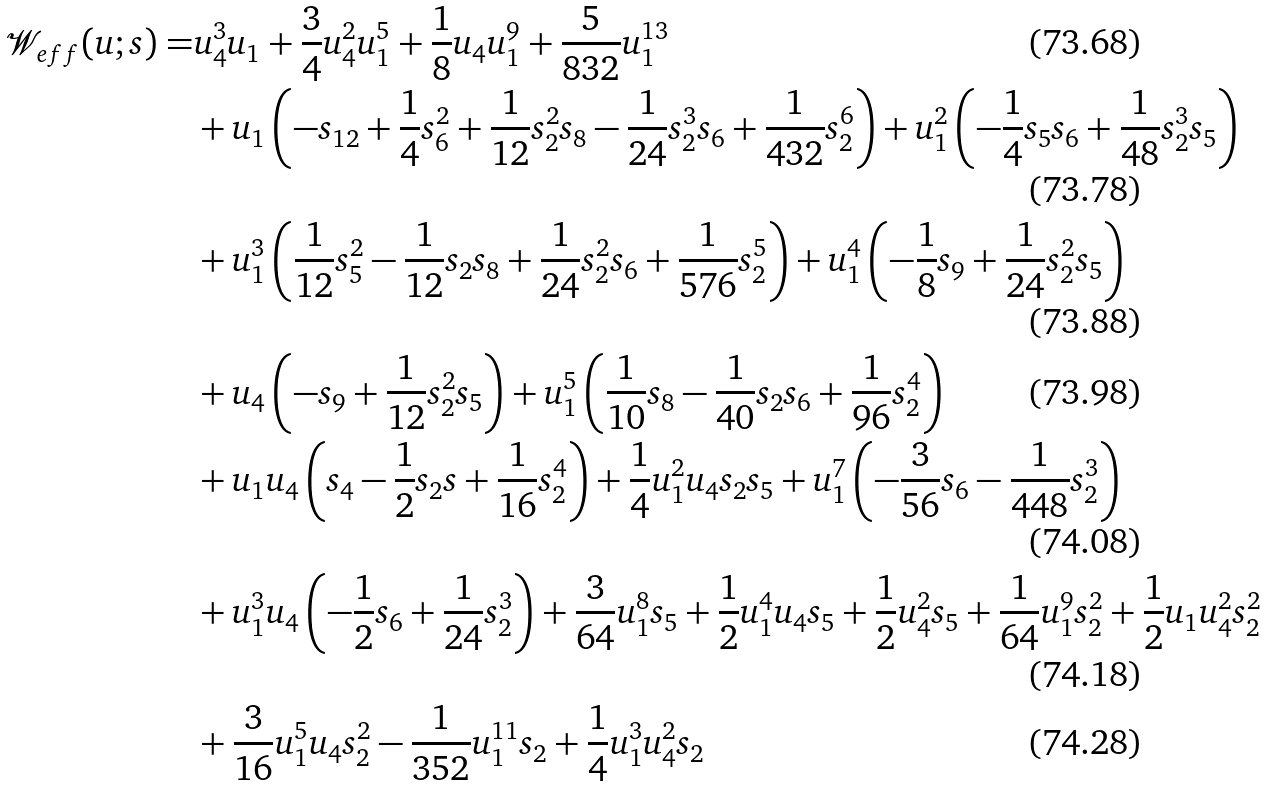<formula> <loc_0><loc_0><loc_500><loc_500>\mathcal { W } _ { e f f } ( u ; s ) = & u _ { 4 } ^ { 3 } u _ { 1 } + \frac { 3 } { 4 } u _ { 4 } ^ { 2 } u _ { 1 } ^ { 5 } + \frac { 1 } { 8 } u _ { 4 } u _ { 1 } ^ { 9 } + \frac { 5 } { 8 3 2 } u _ { 1 } ^ { 1 3 } \\ & + u _ { 1 } \left ( - s _ { 1 2 } + \frac { 1 } { 4 } s _ { 6 } ^ { 2 } + \frac { 1 } { 1 2 } s _ { 2 } ^ { 2 } s _ { 8 } - \frac { 1 } { 2 4 } s _ { 2 } ^ { 3 } s _ { 6 } + \frac { 1 } { 4 3 2 } s _ { 2 } ^ { 6 } \right ) + u _ { 1 } ^ { 2 } \left ( - \frac { 1 } { 4 } s _ { 5 } s _ { 6 } + \frac { 1 } { 4 8 } s _ { 2 } ^ { 3 } s _ { 5 } \right ) \\ & + u _ { 1 } ^ { 3 } \left ( \frac { 1 } { 1 2 } s _ { 5 } ^ { 2 } - \frac { 1 } { 1 2 } s _ { 2 } s _ { 8 } + \frac { 1 } { 2 4 } s _ { 2 } ^ { 2 } s _ { 6 } + \frac { 1 } { 5 7 6 } s _ { 2 } ^ { 5 } \right ) + u _ { 1 } ^ { 4 } \left ( - \frac { 1 } { 8 } s _ { 9 } + \frac { 1 } { 2 4 } s _ { 2 } ^ { 2 } s _ { 5 } \right ) \\ & + u _ { 4 } \left ( - s _ { 9 } + \frac { 1 } { 1 2 } s _ { 2 } ^ { 2 } s _ { 5 } \right ) + u _ { 1 } ^ { 5 } \left ( \frac { 1 } { 1 0 } s _ { 8 } - \frac { 1 } { 4 0 } s _ { 2 } s _ { 6 } + \frac { 1 } { 9 6 } s _ { 2 } ^ { 4 } \right ) \\ & + u _ { 1 } u _ { 4 } \left ( s _ { 4 } - \frac { 1 } { 2 } s _ { 2 } s + \frac { 1 } { 1 6 } s _ { 2 } ^ { 4 } \right ) + \frac { 1 } { 4 } u _ { 1 } ^ { 2 } u _ { 4 } s _ { 2 } s _ { 5 } + u _ { 1 } ^ { 7 } \left ( - \frac { 3 } { 5 6 } s _ { 6 } - \frac { 1 } { 4 4 8 } s _ { 2 } ^ { 3 } \right ) \\ & + u _ { 1 } ^ { 3 } u _ { 4 } \left ( - \frac { 1 } { 2 } s _ { 6 } + \frac { 1 } { 2 4 } s _ { 2 } ^ { 3 } \right ) + \frac { 3 } { 6 4 } u _ { 1 } ^ { 8 } s _ { 5 } + \frac { 1 } { 2 } u _ { 1 } ^ { 4 } u _ { 4 } s _ { 5 } + \frac { 1 } { 2 } u _ { 4 } ^ { 2 } s _ { 5 } + \frac { 1 } { 6 4 } u _ { 1 } ^ { 9 } s _ { 2 } ^ { 2 } + \frac { 1 } { 2 } u _ { 1 } u _ { 4 } ^ { 2 } s _ { 2 } ^ { 2 } \\ & + \frac { 3 } { 1 6 } u _ { 1 } ^ { 5 } u _ { 4 } s _ { 2 } ^ { 2 } - \frac { 1 } { 3 5 2 } u _ { 1 } ^ { 1 1 } s _ { 2 } + \frac { 1 } { 4 } u _ { 1 } ^ { 3 } u _ { 4 } ^ { 2 } s _ { 2 }</formula> 